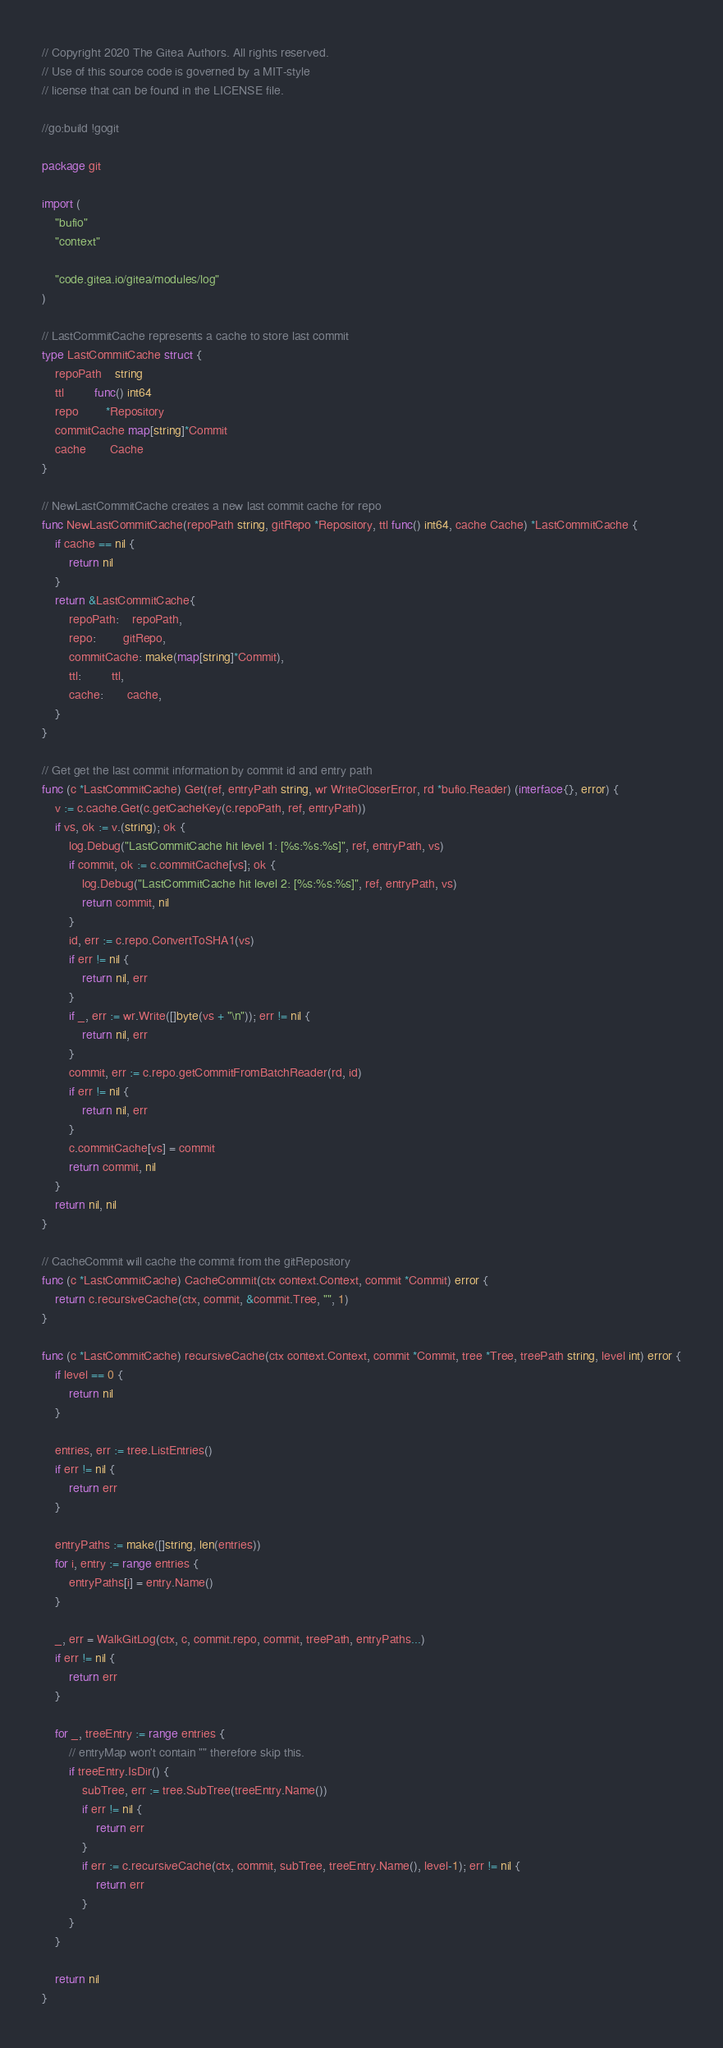Convert code to text. <code><loc_0><loc_0><loc_500><loc_500><_Go_>// Copyright 2020 The Gitea Authors. All rights reserved.
// Use of this source code is governed by a MIT-style
// license that can be found in the LICENSE file.

//go:build !gogit

package git

import (
	"bufio"
	"context"

	"code.gitea.io/gitea/modules/log"
)

// LastCommitCache represents a cache to store last commit
type LastCommitCache struct {
	repoPath    string
	ttl         func() int64
	repo        *Repository
	commitCache map[string]*Commit
	cache       Cache
}

// NewLastCommitCache creates a new last commit cache for repo
func NewLastCommitCache(repoPath string, gitRepo *Repository, ttl func() int64, cache Cache) *LastCommitCache {
	if cache == nil {
		return nil
	}
	return &LastCommitCache{
		repoPath:    repoPath,
		repo:        gitRepo,
		commitCache: make(map[string]*Commit),
		ttl:         ttl,
		cache:       cache,
	}
}

// Get get the last commit information by commit id and entry path
func (c *LastCommitCache) Get(ref, entryPath string, wr WriteCloserError, rd *bufio.Reader) (interface{}, error) {
	v := c.cache.Get(c.getCacheKey(c.repoPath, ref, entryPath))
	if vs, ok := v.(string); ok {
		log.Debug("LastCommitCache hit level 1: [%s:%s:%s]", ref, entryPath, vs)
		if commit, ok := c.commitCache[vs]; ok {
			log.Debug("LastCommitCache hit level 2: [%s:%s:%s]", ref, entryPath, vs)
			return commit, nil
		}
		id, err := c.repo.ConvertToSHA1(vs)
		if err != nil {
			return nil, err
		}
		if _, err := wr.Write([]byte(vs + "\n")); err != nil {
			return nil, err
		}
		commit, err := c.repo.getCommitFromBatchReader(rd, id)
		if err != nil {
			return nil, err
		}
		c.commitCache[vs] = commit
		return commit, nil
	}
	return nil, nil
}

// CacheCommit will cache the commit from the gitRepository
func (c *LastCommitCache) CacheCommit(ctx context.Context, commit *Commit) error {
	return c.recursiveCache(ctx, commit, &commit.Tree, "", 1)
}

func (c *LastCommitCache) recursiveCache(ctx context.Context, commit *Commit, tree *Tree, treePath string, level int) error {
	if level == 0 {
		return nil
	}

	entries, err := tree.ListEntries()
	if err != nil {
		return err
	}

	entryPaths := make([]string, len(entries))
	for i, entry := range entries {
		entryPaths[i] = entry.Name()
	}

	_, err = WalkGitLog(ctx, c, commit.repo, commit, treePath, entryPaths...)
	if err != nil {
		return err
	}

	for _, treeEntry := range entries {
		// entryMap won't contain "" therefore skip this.
		if treeEntry.IsDir() {
			subTree, err := tree.SubTree(treeEntry.Name())
			if err != nil {
				return err
			}
			if err := c.recursiveCache(ctx, commit, subTree, treeEntry.Name(), level-1); err != nil {
				return err
			}
		}
	}

	return nil
}
</code> 